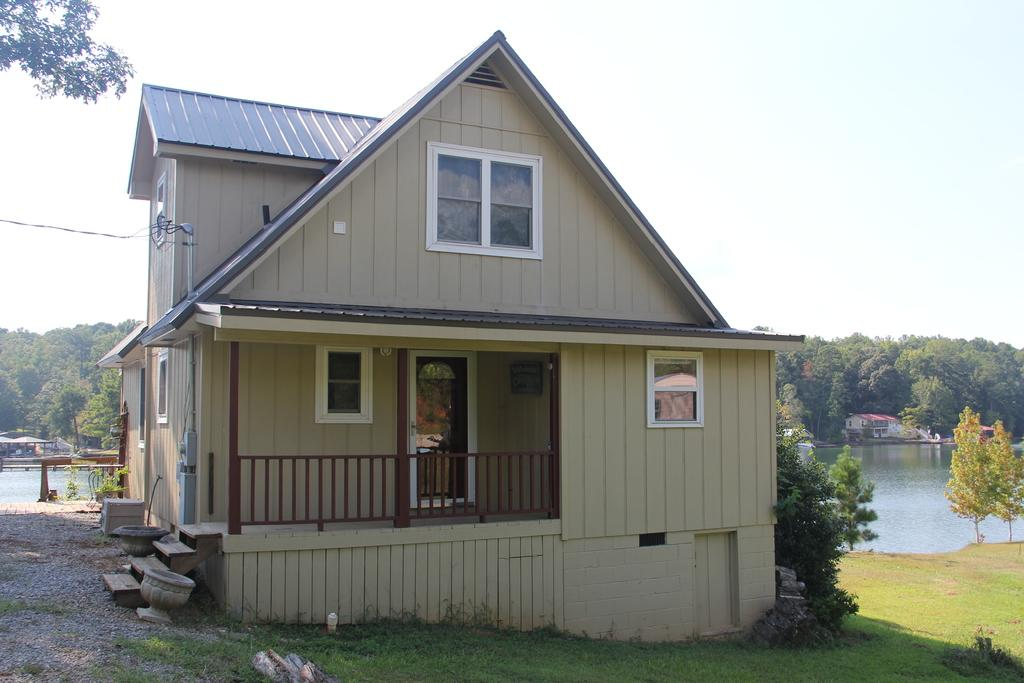What type of structures can be seen in the image? There are houses in the image. What natural elements are present in the image? There are trees, water, grass, and the sky visible in the image. What man-made objects can be seen in the image? Cables, a shed, and stones are visible in the image. What type of paste is being used to hold the houses together in the image? There is no indication in the image that any paste is being used to hold the houses together. What day of the week is depicted in the image? The image does not depict a specific day of the week; it is a still image. 